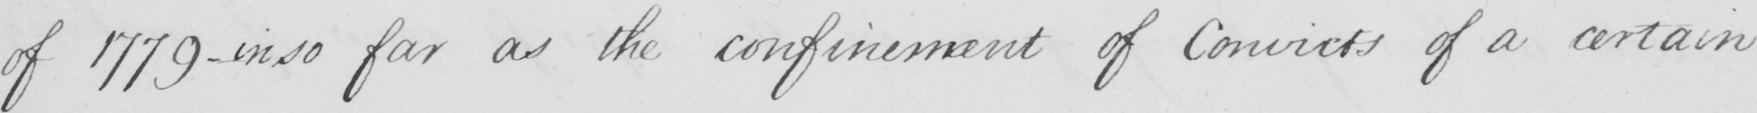Can you read and transcribe this handwriting? of 1779  _  in so far as the confinement of Convicts of a certain 